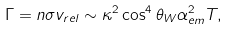<formula> <loc_0><loc_0><loc_500><loc_500>\Gamma = n \sigma v _ { r e l } \sim \kappa ^ { 2 } \cos ^ { 4 } \theta _ { W } \alpha ^ { 2 } _ { e m } T ,</formula> 